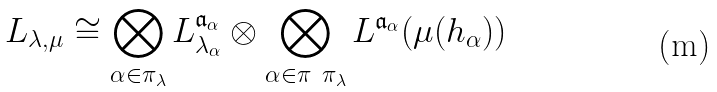Convert formula to latex. <formula><loc_0><loc_0><loc_500><loc_500>L _ { \lambda , \mu } \cong \bigotimes _ { \alpha \in \pi _ { \lambda } } L ^ { \mathfrak { a } _ { \alpha } } _ { \lambda _ { \alpha } } \otimes \bigotimes _ { \alpha \in \pi \ \pi _ { \lambda } } L ^ { \mathfrak { a } _ { \alpha } } ( \mu ( h _ { \alpha } ) )</formula> 